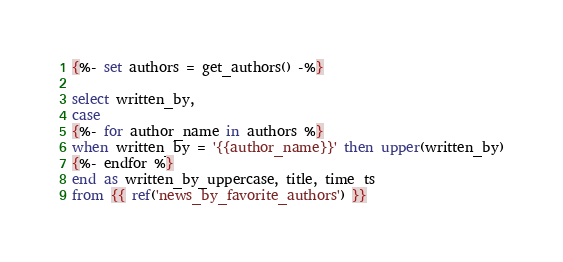Convert code to text. <code><loc_0><loc_0><loc_500><loc_500><_SQL_>{%- set authors = get_authors() -%}

select written_by,
case 
{%- for author_name in authors %}
when written_by = '{{author_name}}' then upper(written_by)
{%- endfor %}
end as written_by_uppercase, title, time_ts
from {{ ref('news_by_favorite_authors') }}
</code> 